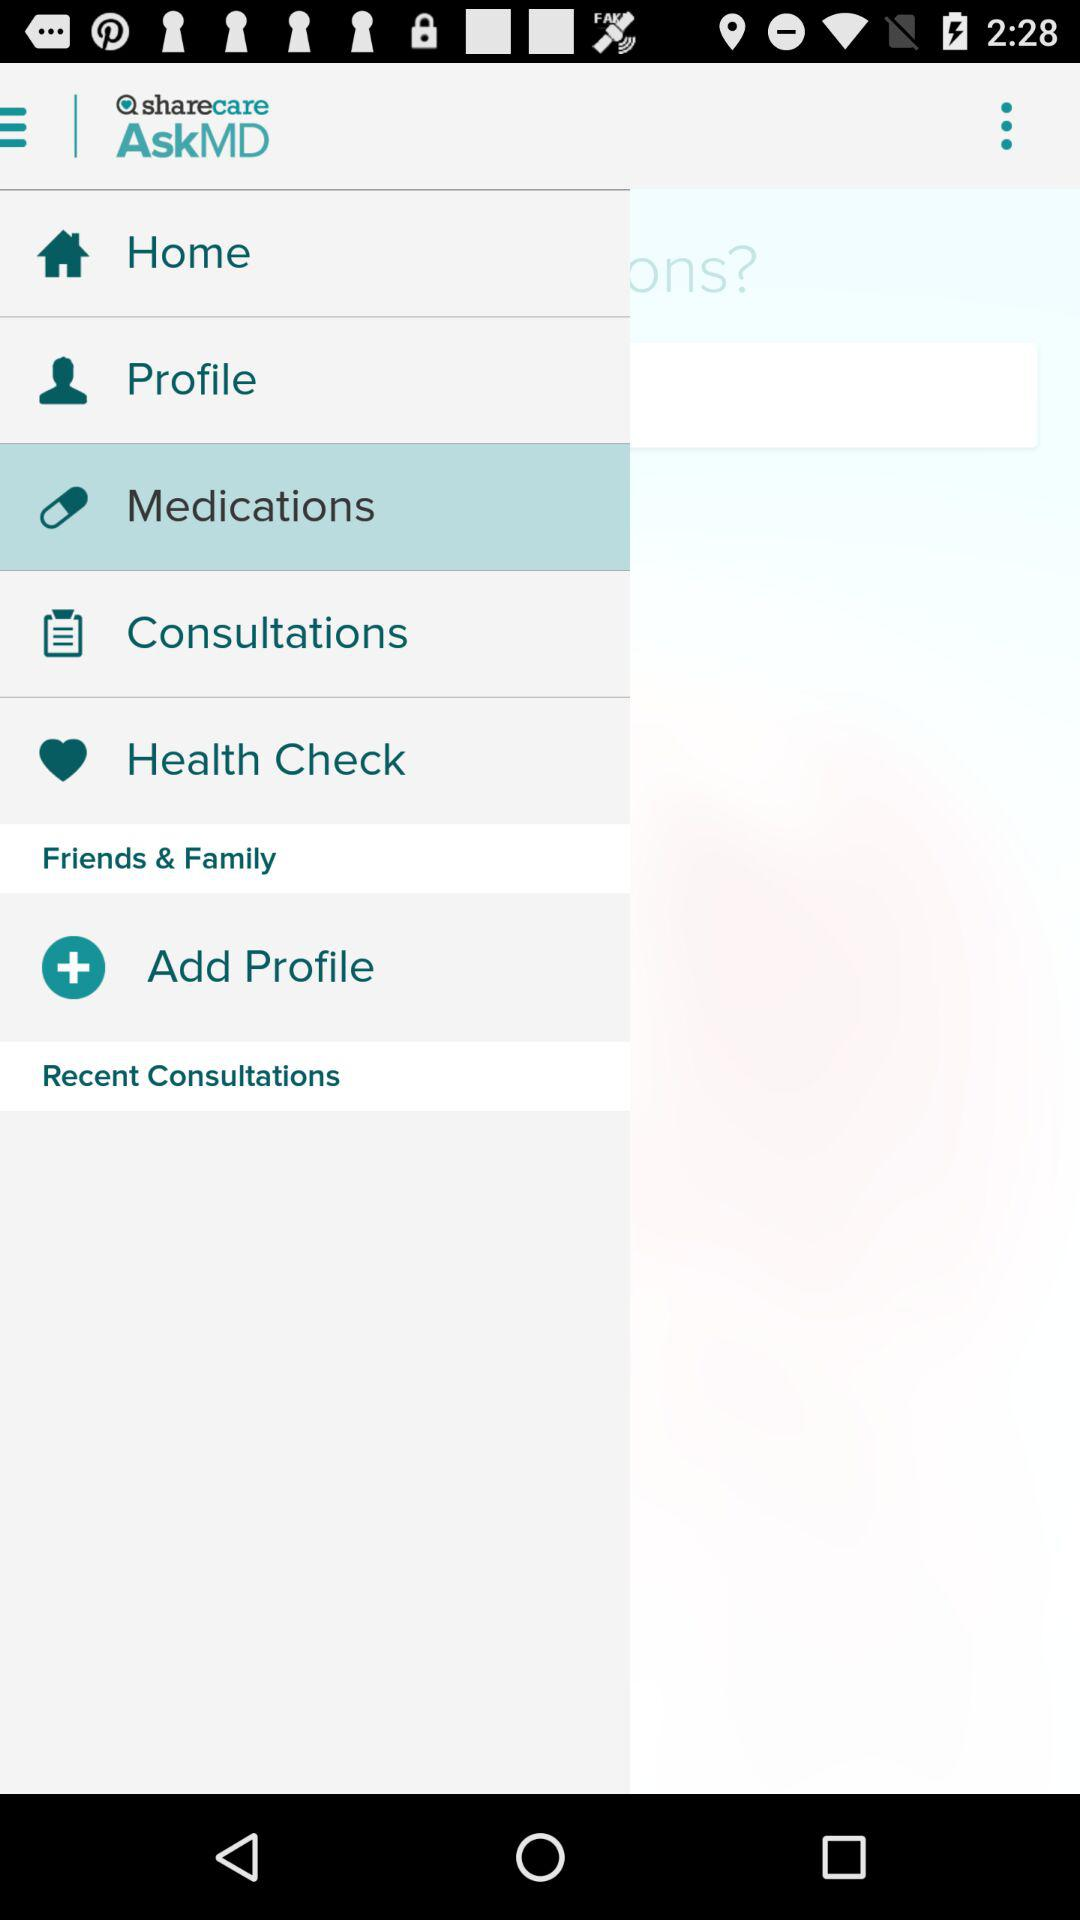What is the application name? The application name is "AskMD". 